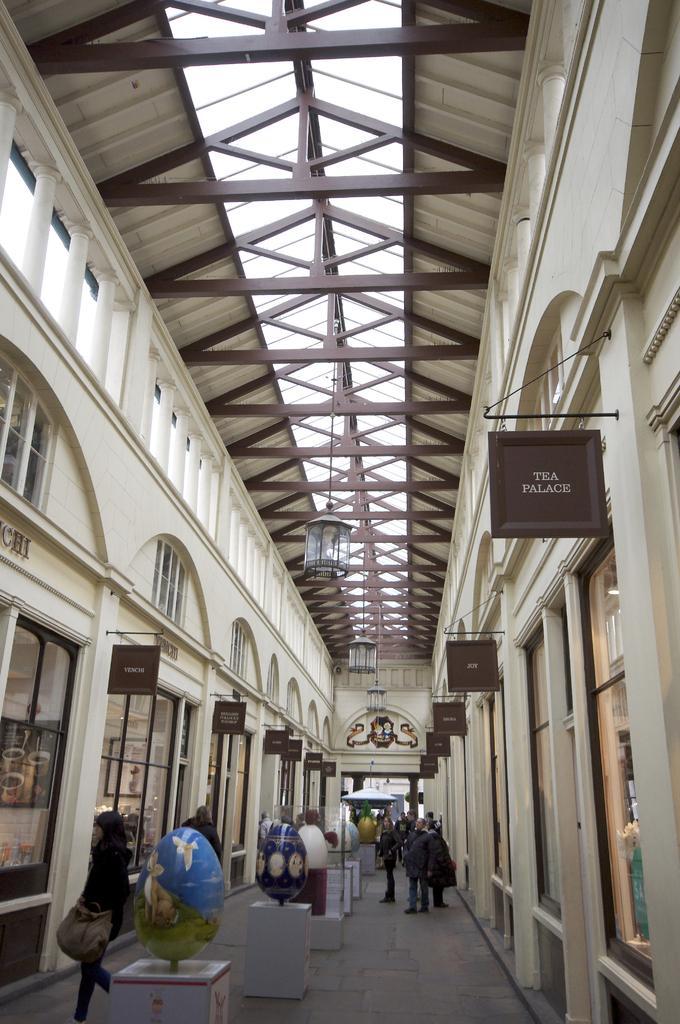Could you give a brief overview of what you see in this image? In this picture we can see some persons standing and in front of them we can see stand with gloves on it and beside to them we have pillars, wall, name boards, lamp to roof. 